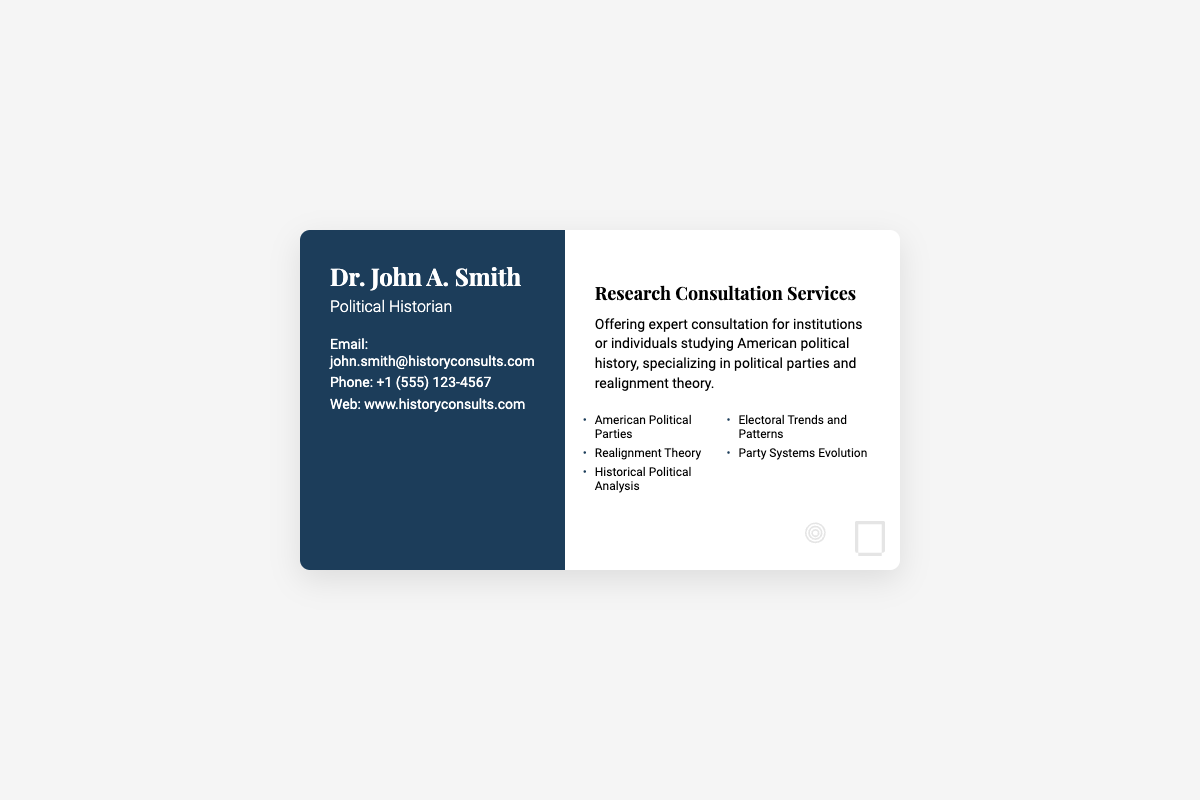What is the name of the political historian? The name is prominently displayed at the top left of the card.
Answer: Dr. John A. Smith What is the email address provided? The email address is listed under the contact info section on the left side of the card.
Answer: john.smith@historyconsults.com What are the areas of expertise listed? The areas of expertise are shown in a bulleted list on the right side of the card.
Answer: American Political Parties, Realignment Theory, Historical Political Analysis, Electoral Trends and Patterns, Party Systems Evolution What title is listed on the business card? The title appears just under the name on the left side of the card.
Answer: Political Historian How many sections are there on the business card? The card is structured into two distinct sections: left and right.
Answer: Two What service is offered according to the card? The card explicitly states the primary service being offered in the designated section.
Answer: Research Consultation Services What is the contact phone number? The phone number is located beneath the email address in the contact info section.
Answer: +1 (555) 123-4567 What background images appear on the card? The background images are shown at the bottom right corner and identify specific themes.
Answer: Political insignia and Historical document What font styles are used in the business card? The card displays two distinct font families for different text elements.
Answer: Playfair Display and Roboto 